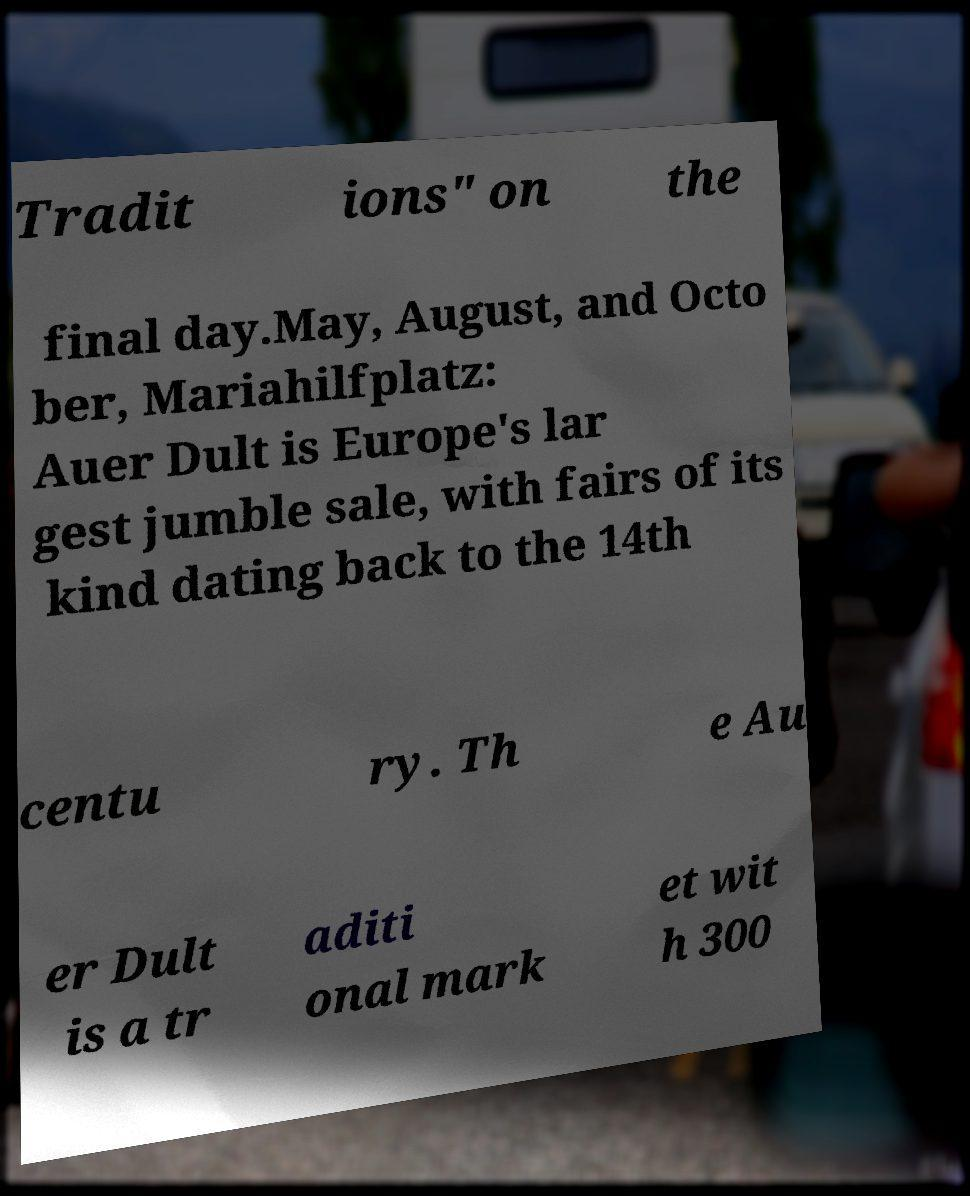Can you read and provide the text displayed in the image?This photo seems to have some interesting text. Can you extract and type it out for me? Tradit ions" on the final day.May, August, and Octo ber, Mariahilfplatz: Auer Dult is Europe's lar gest jumble sale, with fairs of its kind dating back to the 14th centu ry. Th e Au er Dult is a tr aditi onal mark et wit h 300 